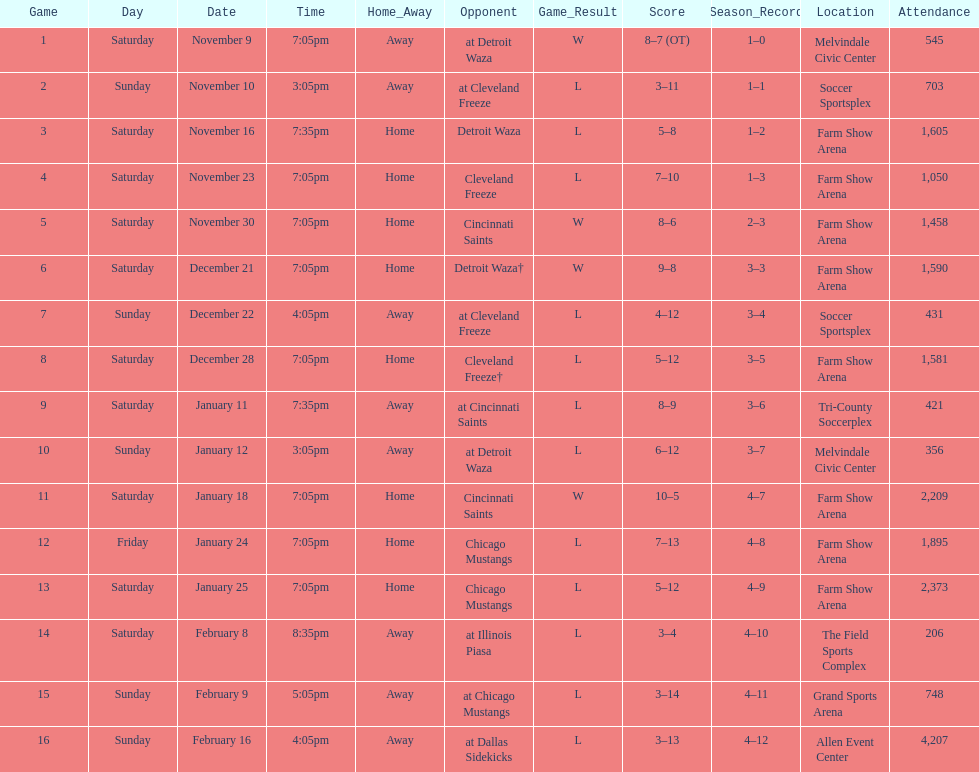Who was the first opponent on this list? Detroit Waza. 